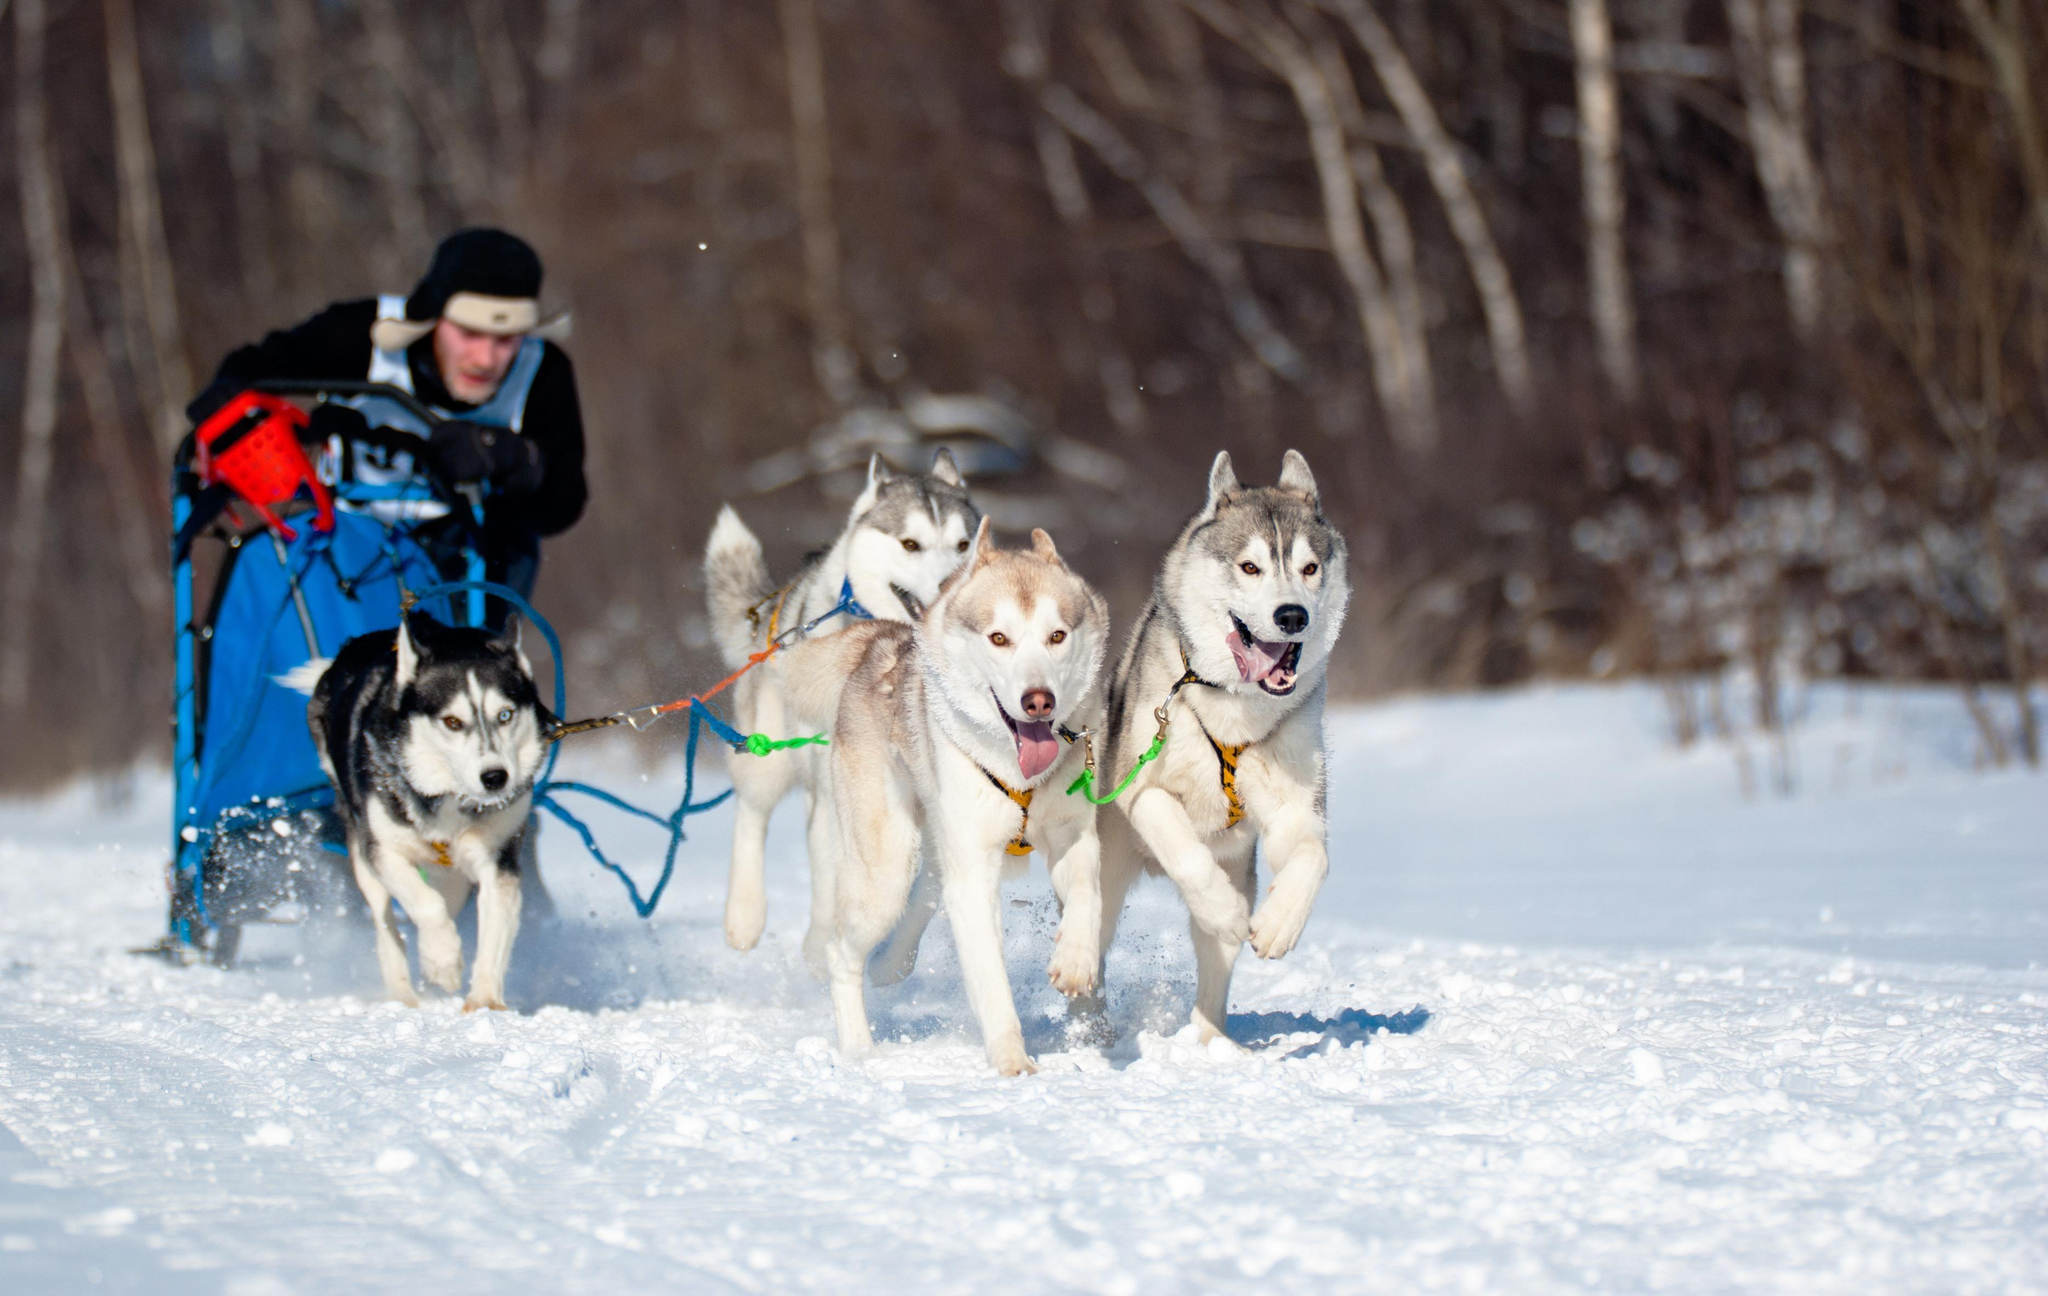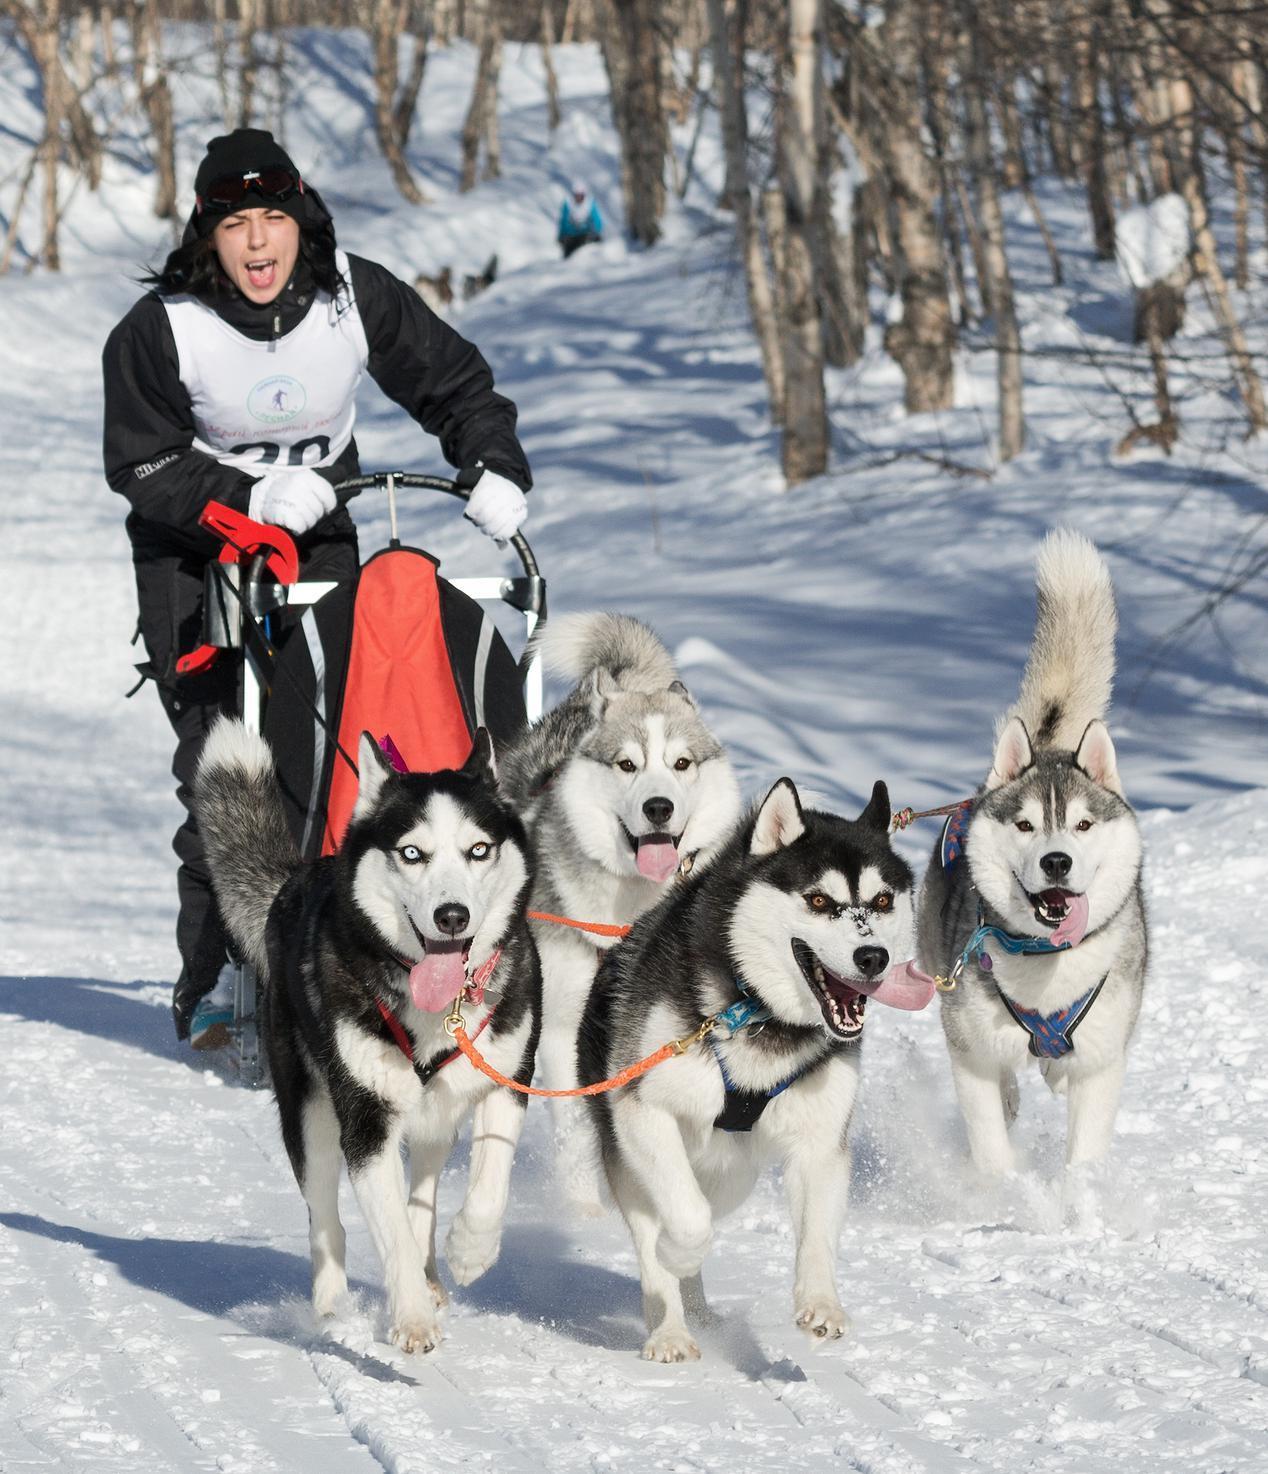The first image is the image on the left, the second image is the image on the right. Given the left and right images, does the statement "There are four dogs on the left image" hold true? Answer yes or no. Yes. 